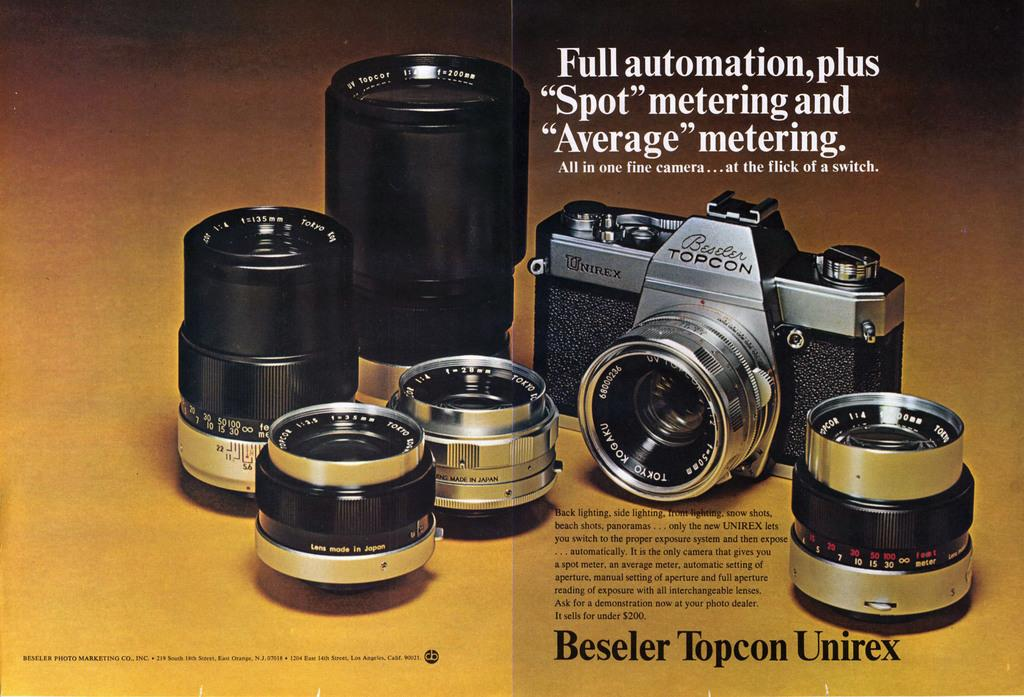What is the main subject of the poster in the image? The poster contains an image of a camera. Are there any other related items depicted on the poster? Yes, the poster also contains images of lenses. What can be found on the right side of the image? There is an article about the camera on the right side of the image. How many strings are attached to the camera in the image? There are no strings attached to the camera in the image. Can you describe the men in the image? There are no men present in the image; it only features a poster with a camera and lenses, and an article about the camera. 